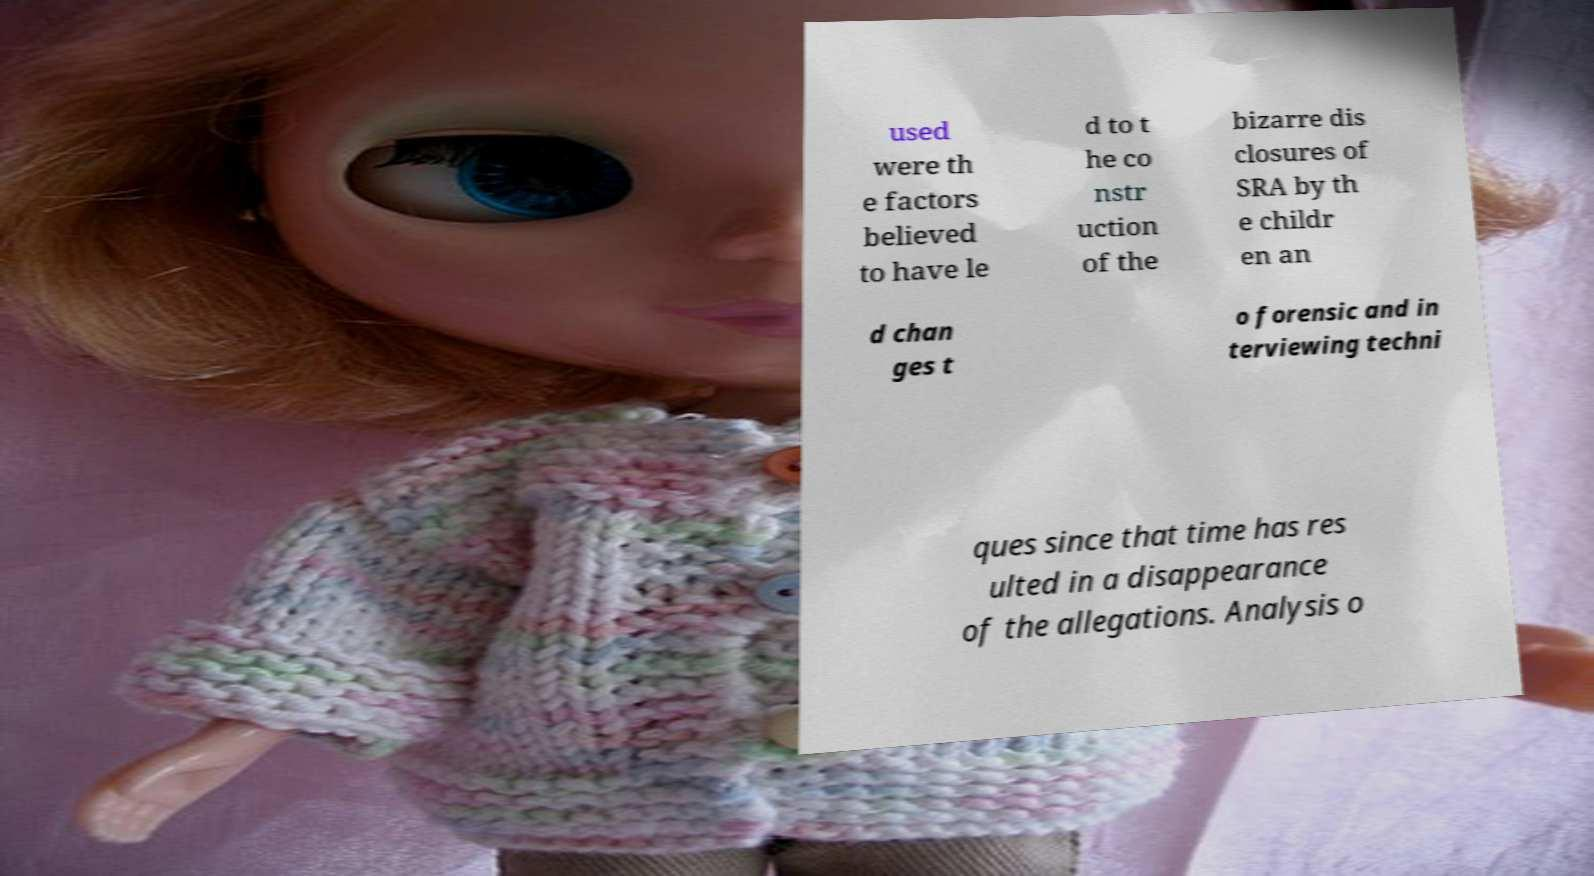What messages or text are displayed in this image? I need them in a readable, typed format. used were th e factors believed to have le d to t he co nstr uction of the bizarre dis closures of SRA by th e childr en an d chan ges t o forensic and in terviewing techni ques since that time has res ulted in a disappearance of the allegations. Analysis o 